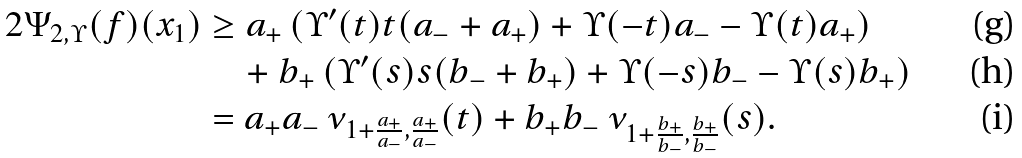Convert formula to latex. <formula><loc_0><loc_0><loc_500><loc_500>2 \Psi _ { 2 , \Upsilon } ( f ) ( x _ { 1 } ) & \geq a _ { + } \left ( \Upsilon ^ { \prime } ( t ) t ( a _ { - } + a _ { + } ) + \Upsilon ( - t ) a _ { - } - \Upsilon ( t ) a _ { + } \right ) \\ & \quad + b _ { + } \left ( \Upsilon ^ { \prime } ( s ) s ( b _ { - } + b _ { + } ) + \Upsilon ( - s ) b _ { - } - \Upsilon ( s ) b _ { + } \right ) \\ & = a _ { + } a _ { - } \, \nu _ { 1 + \frac { a _ { + } } { a _ { - } } , \frac { a _ { + } } { a _ { - } } } ( t ) + b _ { + } b _ { - } \, \nu _ { 1 + \frac { b _ { + } } { b _ { - } } , \frac { b _ { + } } { b _ { - } } } ( s ) .</formula> 